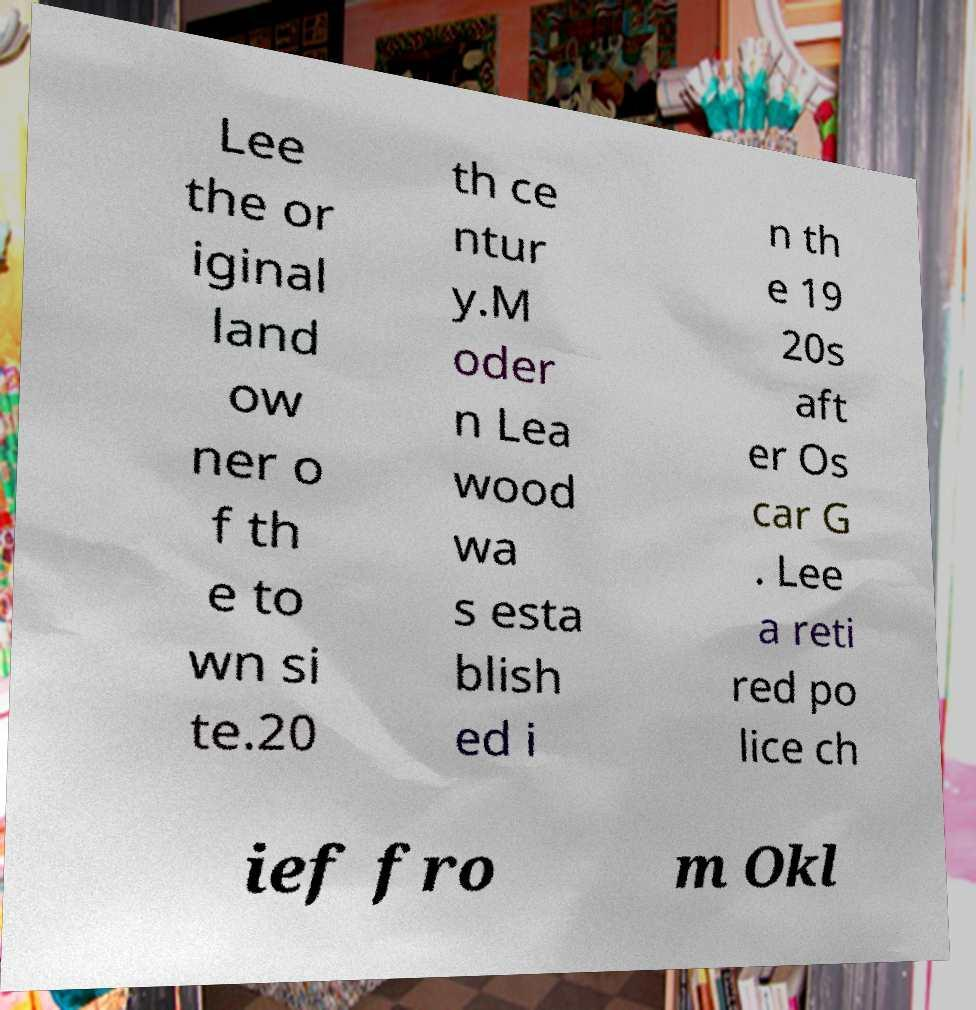Can you accurately transcribe the text from the provided image for me? Lee the or iginal land ow ner o f th e to wn si te.20 th ce ntur y.M oder n Lea wood wa s esta blish ed i n th e 19 20s aft er Os car G . Lee a reti red po lice ch ief fro m Okl 